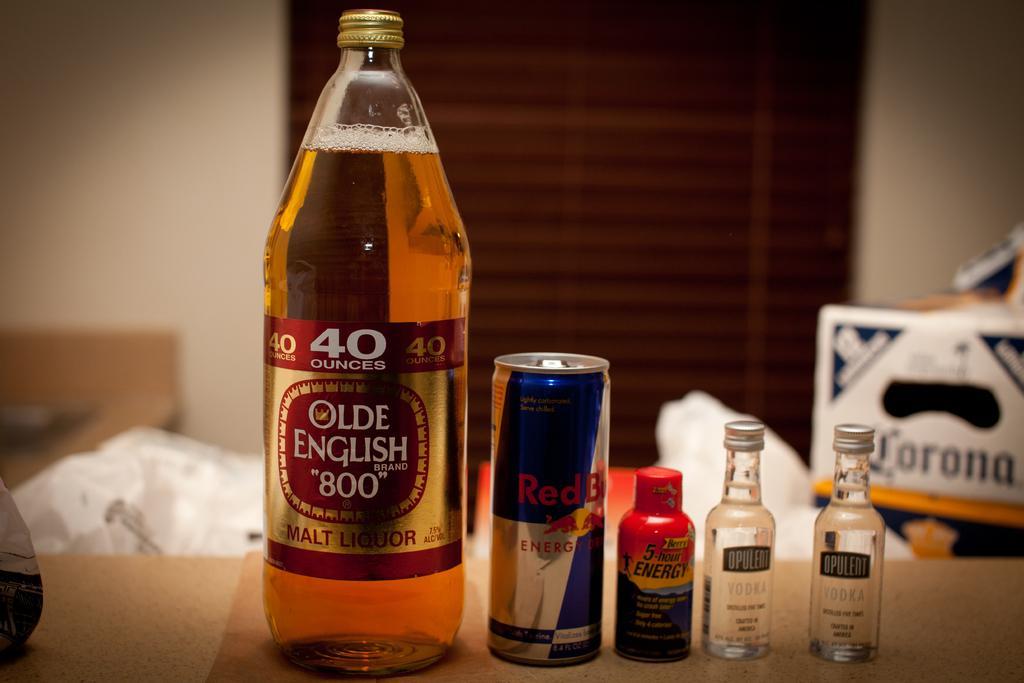How would you summarize this image in a sentence or two? In this image there is a malt liquor bottle in which drink is there. Beside there is a drink can and three bottles. Back to these, there is a cardboard box. Background there is a wall and a door. 